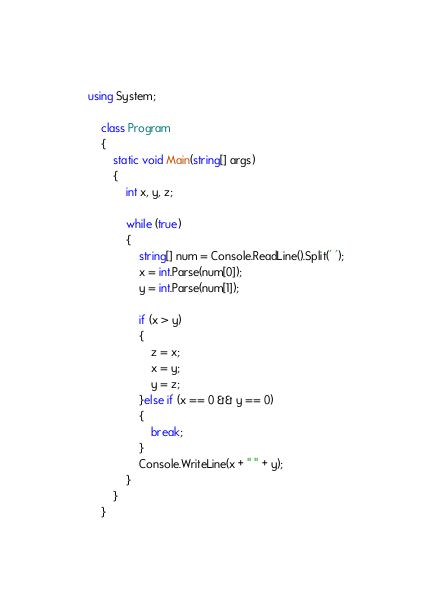<code> <loc_0><loc_0><loc_500><loc_500><_C#_>using System;

    class Program
    {
        static void Main(string[] args)
        {
            int x, y, z;

            while (true)
            {
                string[] num = Console.ReadLine().Split(' ');
                x = int.Parse(num[0]);
                y = int.Parse(num[1]);

                if (x > y)
                {
                    z = x;
                    x = y;
                    y = z;
                }else if (x == 0 && y == 0)
                {
                    break;
                }
                Console.WriteLine(x + " " + y);   
            }
        }
    }

</code> 